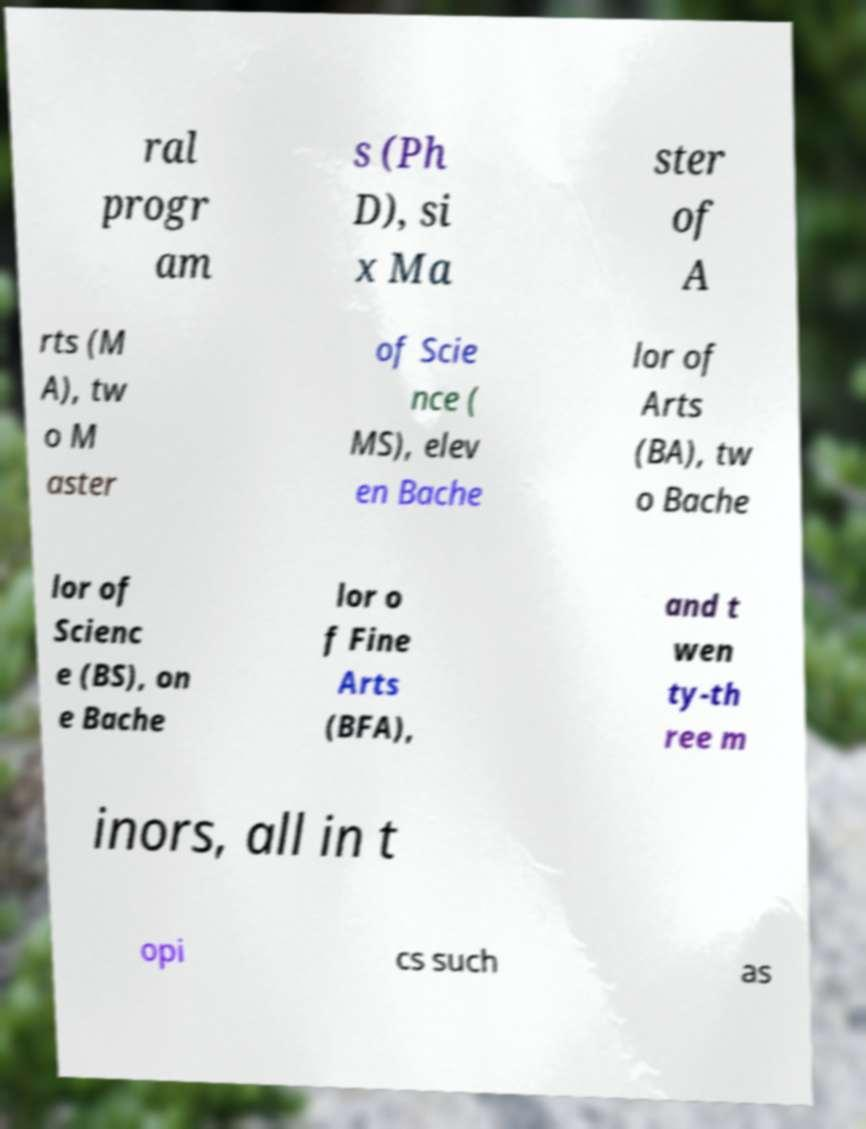Can you accurately transcribe the text from the provided image for me? ral progr am s (Ph D), si x Ma ster of A rts (M A), tw o M aster of Scie nce ( MS), elev en Bache lor of Arts (BA), tw o Bache lor of Scienc e (BS), on e Bache lor o f Fine Arts (BFA), and t wen ty-th ree m inors, all in t opi cs such as 